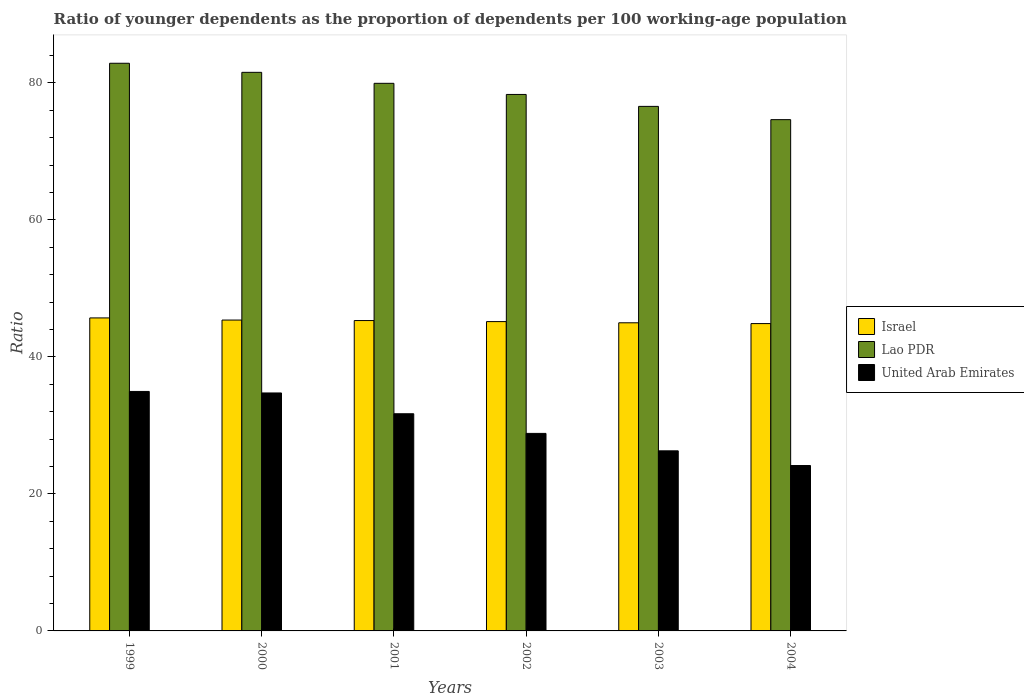How many bars are there on the 2nd tick from the left?
Ensure brevity in your answer.  3. How many bars are there on the 5th tick from the right?
Your answer should be very brief. 3. What is the label of the 1st group of bars from the left?
Give a very brief answer. 1999. What is the age dependency ratio(young) in Israel in 2000?
Offer a terse response. 45.38. Across all years, what is the maximum age dependency ratio(young) in United Arab Emirates?
Keep it short and to the point. 34.96. Across all years, what is the minimum age dependency ratio(young) in Israel?
Your response must be concise. 44.87. In which year was the age dependency ratio(young) in Lao PDR minimum?
Your answer should be compact. 2004. What is the total age dependency ratio(young) in Israel in the graph?
Make the answer very short. 271.39. What is the difference between the age dependency ratio(young) in Lao PDR in 1999 and that in 2002?
Offer a terse response. 4.55. What is the difference between the age dependency ratio(young) in Lao PDR in 2003 and the age dependency ratio(young) in Israel in 2002?
Offer a very short reply. 31.42. What is the average age dependency ratio(young) in Lao PDR per year?
Make the answer very short. 78.98. In the year 1999, what is the difference between the age dependency ratio(young) in Israel and age dependency ratio(young) in United Arab Emirates?
Your response must be concise. 10.73. In how many years, is the age dependency ratio(young) in United Arab Emirates greater than 12?
Provide a short and direct response. 6. What is the ratio of the age dependency ratio(young) in Lao PDR in 1999 to that in 2000?
Give a very brief answer. 1.02. Is the age dependency ratio(young) in Lao PDR in 1999 less than that in 2002?
Keep it short and to the point. No. Is the difference between the age dependency ratio(young) in Israel in 2000 and 2003 greater than the difference between the age dependency ratio(young) in United Arab Emirates in 2000 and 2003?
Make the answer very short. No. What is the difference between the highest and the second highest age dependency ratio(young) in Israel?
Provide a short and direct response. 0.31. What is the difference between the highest and the lowest age dependency ratio(young) in Lao PDR?
Offer a terse response. 8.23. In how many years, is the age dependency ratio(young) in Lao PDR greater than the average age dependency ratio(young) in Lao PDR taken over all years?
Keep it short and to the point. 3. Is the sum of the age dependency ratio(young) in United Arab Emirates in 2003 and 2004 greater than the maximum age dependency ratio(young) in Israel across all years?
Offer a very short reply. Yes. What does the 1st bar from the left in 1999 represents?
Your response must be concise. Israel. What does the 2nd bar from the right in 2004 represents?
Your answer should be very brief. Lao PDR. Is it the case that in every year, the sum of the age dependency ratio(young) in Lao PDR and age dependency ratio(young) in Israel is greater than the age dependency ratio(young) in United Arab Emirates?
Provide a succinct answer. Yes. How many bars are there?
Provide a short and direct response. 18. Are all the bars in the graph horizontal?
Provide a succinct answer. No. What is the difference between two consecutive major ticks on the Y-axis?
Your response must be concise. 20. Where does the legend appear in the graph?
Provide a succinct answer. Center right. How are the legend labels stacked?
Your response must be concise. Vertical. What is the title of the graph?
Your response must be concise. Ratio of younger dependents as the proportion of dependents per 100 working-age population. Does "Niger" appear as one of the legend labels in the graph?
Your answer should be very brief. No. What is the label or title of the Y-axis?
Your response must be concise. Ratio. What is the Ratio of Israel in 1999?
Give a very brief answer. 45.69. What is the Ratio in Lao PDR in 1999?
Ensure brevity in your answer.  82.87. What is the Ratio in United Arab Emirates in 1999?
Offer a terse response. 34.96. What is the Ratio of Israel in 2000?
Your response must be concise. 45.38. What is the Ratio of Lao PDR in 2000?
Your answer should be very brief. 81.54. What is the Ratio of United Arab Emirates in 2000?
Give a very brief answer. 34.74. What is the Ratio of Israel in 2001?
Offer a terse response. 45.31. What is the Ratio in Lao PDR in 2001?
Offer a very short reply. 79.94. What is the Ratio of United Arab Emirates in 2001?
Your answer should be compact. 31.7. What is the Ratio in Israel in 2002?
Give a very brief answer. 45.16. What is the Ratio of Lao PDR in 2002?
Your response must be concise. 78.32. What is the Ratio of United Arab Emirates in 2002?
Offer a terse response. 28.84. What is the Ratio in Israel in 2003?
Offer a terse response. 44.98. What is the Ratio of Lao PDR in 2003?
Make the answer very short. 76.57. What is the Ratio of United Arab Emirates in 2003?
Provide a short and direct response. 26.29. What is the Ratio of Israel in 2004?
Give a very brief answer. 44.87. What is the Ratio in Lao PDR in 2004?
Your response must be concise. 74.64. What is the Ratio in United Arab Emirates in 2004?
Give a very brief answer. 24.15. Across all years, what is the maximum Ratio in Israel?
Make the answer very short. 45.69. Across all years, what is the maximum Ratio in Lao PDR?
Keep it short and to the point. 82.87. Across all years, what is the maximum Ratio in United Arab Emirates?
Your answer should be very brief. 34.96. Across all years, what is the minimum Ratio in Israel?
Keep it short and to the point. 44.87. Across all years, what is the minimum Ratio of Lao PDR?
Your answer should be compact. 74.64. Across all years, what is the minimum Ratio in United Arab Emirates?
Provide a succinct answer. 24.15. What is the total Ratio of Israel in the graph?
Provide a succinct answer. 271.39. What is the total Ratio of Lao PDR in the graph?
Keep it short and to the point. 473.89. What is the total Ratio of United Arab Emirates in the graph?
Give a very brief answer. 180.67. What is the difference between the Ratio in Israel in 1999 and that in 2000?
Your answer should be very brief. 0.31. What is the difference between the Ratio in Lao PDR in 1999 and that in 2000?
Offer a very short reply. 1.33. What is the difference between the Ratio in United Arab Emirates in 1999 and that in 2000?
Your answer should be compact. 0.22. What is the difference between the Ratio in Israel in 1999 and that in 2001?
Ensure brevity in your answer.  0.39. What is the difference between the Ratio in Lao PDR in 1999 and that in 2001?
Offer a terse response. 2.93. What is the difference between the Ratio in United Arab Emirates in 1999 and that in 2001?
Make the answer very short. 3.26. What is the difference between the Ratio of Israel in 1999 and that in 2002?
Your response must be concise. 0.54. What is the difference between the Ratio in Lao PDR in 1999 and that in 2002?
Offer a very short reply. 4.55. What is the difference between the Ratio of United Arab Emirates in 1999 and that in 2002?
Offer a very short reply. 6.12. What is the difference between the Ratio of Israel in 1999 and that in 2003?
Provide a succinct answer. 0.71. What is the difference between the Ratio of Lao PDR in 1999 and that in 2003?
Provide a short and direct response. 6.3. What is the difference between the Ratio in United Arab Emirates in 1999 and that in 2003?
Make the answer very short. 8.67. What is the difference between the Ratio in Israel in 1999 and that in 2004?
Make the answer very short. 0.83. What is the difference between the Ratio of Lao PDR in 1999 and that in 2004?
Ensure brevity in your answer.  8.23. What is the difference between the Ratio in United Arab Emirates in 1999 and that in 2004?
Offer a terse response. 10.81. What is the difference between the Ratio in Israel in 2000 and that in 2001?
Provide a short and direct response. 0.07. What is the difference between the Ratio in Lao PDR in 2000 and that in 2001?
Offer a very short reply. 1.6. What is the difference between the Ratio in United Arab Emirates in 2000 and that in 2001?
Make the answer very short. 3.03. What is the difference between the Ratio in Israel in 2000 and that in 2002?
Offer a very short reply. 0.22. What is the difference between the Ratio of Lao PDR in 2000 and that in 2002?
Ensure brevity in your answer.  3.23. What is the difference between the Ratio in United Arab Emirates in 2000 and that in 2002?
Your answer should be compact. 5.9. What is the difference between the Ratio in Israel in 2000 and that in 2003?
Ensure brevity in your answer.  0.4. What is the difference between the Ratio of Lao PDR in 2000 and that in 2003?
Offer a terse response. 4.97. What is the difference between the Ratio in United Arab Emirates in 2000 and that in 2003?
Keep it short and to the point. 8.45. What is the difference between the Ratio in Israel in 2000 and that in 2004?
Make the answer very short. 0.51. What is the difference between the Ratio in Lao PDR in 2000 and that in 2004?
Your answer should be compact. 6.91. What is the difference between the Ratio in United Arab Emirates in 2000 and that in 2004?
Provide a short and direct response. 10.59. What is the difference between the Ratio in Israel in 2001 and that in 2002?
Your answer should be very brief. 0.15. What is the difference between the Ratio of Lao PDR in 2001 and that in 2002?
Your response must be concise. 1.62. What is the difference between the Ratio in United Arab Emirates in 2001 and that in 2002?
Offer a terse response. 2.87. What is the difference between the Ratio of Israel in 2001 and that in 2003?
Your response must be concise. 0.33. What is the difference between the Ratio in Lao PDR in 2001 and that in 2003?
Ensure brevity in your answer.  3.37. What is the difference between the Ratio of United Arab Emirates in 2001 and that in 2003?
Your response must be concise. 5.41. What is the difference between the Ratio in Israel in 2001 and that in 2004?
Provide a short and direct response. 0.44. What is the difference between the Ratio in Lao PDR in 2001 and that in 2004?
Your answer should be compact. 5.3. What is the difference between the Ratio in United Arab Emirates in 2001 and that in 2004?
Offer a terse response. 7.56. What is the difference between the Ratio in Israel in 2002 and that in 2003?
Give a very brief answer. 0.17. What is the difference between the Ratio of Lao PDR in 2002 and that in 2003?
Offer a terse response. 1.74. What is the difference between the Ratio of United Arab Emirates in 2002 and that in 2003?
Offer a very short reply. 2.55. What is the difference between the Ratio in Israel in 2002 and that in 2004?
Offer a terse response. 0.29. What is the difference between the Ratio of Lao PDR in 2002 and that in 2004?
Your answer should be compact. 3.68. What is the difference between the Ratio of United Arab Emirates in 2002 and that in 2004?
Give a very brief answer. 4.69. What is the difference between the Ratio of Israel in 2003 and that in 2004?
Offer a terse response. 0.12. What is the difference between the Ratio in Lao PDR in 2003 and that in 2004?
Your answer should be compact. 1.94. What is the difference between the Ratio of United Arab Emirates in 2003 and that in 2004?
Make the answer very short. 2.14. What is the difference between the Ratio of Israel in 1999 and the Ratio of Lao PDR in 2000?
Make the answer very short. -35.85. What is the difference between the Ratio in Israel in 1999 and the Ratio in United Arab Emirates in 2000?
Make the answer very short. 10.96. What is the difference between the Ratio of Lao PDR in 1999 and the Ratio of United Arab Emirates in 2000?
Provide a succinct answer. 48.13. What is the difference between the Ratio of Israel in 1999 and the Ratio of Lao PDR in 2001?
Ensure brevity in your answer.  -34.25. What is the difference between the Ratio in Israel in 1999 and the Ratio in United Arab Emirates in 2001?
Offer a terse response. 13.99. What is the difference between the Ratio in Lao PDR in 1999 and the Ratio in United Arab Emirates in 2001?
Give a very brief answer. 51.17. What is the difference between the Ratio in Israel in 1999 and the Ratio in Lao PDR in 2002?
Make the answer very short. -32.62. What is the difference between the Ratio in Israel in 1999 and the Ratio in United Arab Emirates in 2002?
Your response must be concise. 16.86. What is the difference between the Ratio in Lao PDR in 1999 and the Ratio in United Arab Emirates in 2002?
Give a very brief answer. 54.03. What is the difference between the Ratio in Israel in 1999 and the Ratio in Lao PDR in 2003?
Offer a terse response. -30.88. What is the difference between the Ratio in Israel in 1999 and the Ratio in United Arab Emirates in 2003?
Make the answer very short. 19.4. What is the difference between the Ratio of Lao PDR in 1999 and the Ratio of United Arab Emirates in 2003?
Offer a very short reply. 56.58. What is the difference between the Ratio of Israel in 1999 and the Ratio of Lao PDR in 2004?
Provide a succinct answer. -28.95. What is the difference between the Ratio of Israel in 1999 and the Ratio of United Arab Emirates in 2004?
Provide a short and direct response. 21.55. What is the difference between the Ratio in Lao PDR in 1999 and the Ratio in United Arab Emirates in 2004?
Make the answer very short. 58.72. What is the difference between the Ratio in Israel in 2000 and the Ratio in Lao PDR in 2001?
Offer a very short reply. -34.56. What is the difference between the Ratio of Israel in 2000 and the Ratio of United Arab Emirates in 2001?
Ensure brevity in your answer.  13.68. What is the difference between the Ratio of Lao PDR in 2000 and the Ratio of United Arab Emirates in 2001?
Keep it short and to the point. 49.84. What is the difference between the Ratio in Israel in 2000 and the Ratio in Lao PDR in 2002?
Ensure brevity in your answer.  -32.94. What is the difference between the Ratio in Israel in 2000 and the Ratio in United Arab Emirates in 2002?
Give a very brief answer. 16.55. What is the difference between the Ratio in Lao PDR in 2000 and the Ratio in United Arab Emirates in 2002?
Your answer should be very brief. 52.71. What is the difference between the Ratio in Israel in 2000 and the Ratio in Lao PDR in 2003?
Your response must be concise. -31.19. What is the difference between the Ratio of Israel in 2000 and the Ratio of United Arab Emirates in 2003?
Provide a short and direct response. 19.09. What is the difference between the Ratio in Lao PDR in 2000 and the Ratio in United Arab Emirates in 2003?
Provide a succinct answer. 55.25. What is the difference between the Ratio of Israel in 2000 and the Ratio of Lao PDR in 2004?
Your answer should be very brief. -29.26. What is the difference between the Ratio in Israel in 2000 and the Ratio in United Arab Emirates in 2004?
Offer a very short reply. 21.23. What is the difference between the Ratio in Lao PDR in 2000 and the Ratio in United Arab Emirates in 2004?
Offer a terse response. 57.4. What is the difference between the Ratio of Israel in 2001 and the Ratio of Lao PDR in 2002?
Offer a terse response. -33.01. What is the difference between the Ratio in Israel in 2001 and the Ratio in United Arab Emirates in 2002?
Provide a short and direct response. 16.47. What is the difference between the Ratio of Lao PDR in 2001 and the Ratio of United Arab Emirates in 2002?
Provide a succinct answer. 51.11. What is the difference between the Ratio of Israel in 2001 and the Ratio of Lao PDR in 2003?
Your response must be concise. -31.27. What is the difference between the Ratio in Israel in 2001 and the Ratio in United Arab Emirates in 2003?
Make the answer very short. 19.02. What is the difference between the Ratio in Lao PDR in 2001 and the Ratio in United Arab Emirates in 2003?
Keep it short and to the point. 53.65. What is the difference between the Ratio in Israel in 2001 and the Ratio in Lao PDR in 2004?
Keep it short and to the point. -29.33. What is the difference between the Ratio in Israel in 2001 and the Ratio in United Arab Emirates in 2004?
Give a very brief answer. 21.16. What is the difference between the Ratio of Lao PDR in 2001 and the Ratio of United Arab Emirates in 2004?
Your answer should be very brief. 55.8. What is the difference between the Ratio in Israel in 2002 and the Ratio in Lao PDR in 2003?
Your answer should be compact. -31.42. What is the difference between the Ratio in Israel in 2002 and the Ratio in United Arab Emirates in 2003?
Make the answer very short. 18.87. What is the difference between the Ratio of Lao PDR in 2002 and the Ratio of United Arab Emirates in 2003?
Ensure brevity in your answer.  52.03. What is the difference between the Ratio of Israel in 2002 and the Ratio of Lao PDR in 2004?
Provide a succinct answer. -29.48. What is the difference between the Ratio of Israel in 2002 and the Ratio of United Arab Emirates in 2004?
Your answer should be very brief. 21.01. What is the difference between the Ratio in Lao PDR in 2002 and the Ratio in United Arab Emirates in 2004?
Give a very brief answer. 54.17. What is the difference between the Ratio in Israel in 2003 and the Ratio in Lao PDR in 2004?
Offer a very short reply. -29.66. What is the difference between the Ratio in Israel in 2003 and the Ratio in United Arab Emirates in 2004?
Offer a terse response. 20.84. What is the difference between the Ratio of Lao PDR in 2003 and the Ratio of United Arab Emirates in 2004?
Make the answer very short. 52.43. What is the average Ratio in Israel per year?
Your answer should be very brief. 45.23. What is the average Ratio of Lao PDR per year?
Provide a succinct answer. 78.98. What is the average Ratio in United Arab Emirates per year?
Your response must be concise. 30.11. In the year 1999, what is the difference between the Ratio in Israel and Ratio in Lao PDR?
Your answer should be very brief. -37.18. In the year 1999, what is the difference between the Ratio of Israel and Ratio of United Arab Emirates?
Offer a terse response. 10.73. In the year 1999, what is the difference between the Ratio of Lao PDR and Ratio of United Arab Emirates?
Give a very brief answer. 47.91. In the year 2000, what is the difference between the Ratio in Israel and Ratio in Lao PDR?
Provide a succinct answer. -36.16. In the year 2000, what is the difference between the Ratio in Israel and Ratio in United Arab Emirates?
Your answer should be very brief. 10.64. In the year 2000, what is the difference between the Ratio in Lao PDR and Ratio in United Arab Emirates?
Your response must be concise. 46.81. In the year 2001, what is the difference between the Ratio in Israel and Ratio in Lao PDR?
Your response must be concise. -34.63. In the year 2001, what is the difference between the Ratio in Israel and Ratio in United Arab Emirates?
Your response must be concise. 13.61. In the year 2001, what is the difference between the Ratio of Lao PDR and Ratio of United Arab Emirates?
Offer a terse response. 48.24. In the year 2002, what is the difference between the Ratio in Israel and Ratio in Lao PDR?
Provide a succinct answer. -33.16. In the year 2002, what is the difference between the Ratio of Israel and Ratio of United Arab Emirates?
Keep it short and to the point. 16.32. In the year 2002, what is the difference between the Ratio in Lao PDR and Ratio in United Arab Emirates?
Offer a terse response. 49.48. In the year 2003, what is the difference between the Ratio of Israel and Ratio of Lao PDR?
Your response must be concise. -31.59. In the year 2003, what is the difference between the Ratio in Israel and Ratio in United Arab Emirates?
Offer a very short reply. 18.69. In the year 2003, what is the difference between the Ratio in Lao PDR and Ratio in United Arab Emirates?
Give a very brief answer. 50.28. In the year 2004, what is the difference between the Ratio in Israel and Ratio in Lao PDR?
Give a very brief answer. -29.77. In the year 2004, what is the difference between the Ratio in Israel and Ratio in United Arab Emirates?
Provide a short and direct response. 20.72. In the year 2004, what is the difference between the Ratio in Lao PDR and Ratio in United Arab Emirates?
Your answer should be very brief. 50.49. What is the ratio of the Ratio of Lao PDR in 1999 to that in 2000?
Offer a very short reply. 1.02. What is the ratio of the Ratio in United Arab Emirates in 1999 to that in 2000?
Make the answer very short. 1.01. What is the ratio of the Ratio of Israel in 1999 to that in 2001?
Your answer should be very brief. 1.01. What is the ratio of the Ratio of Lao PDR in 1999 to that in 2001?
Offer a terse response. 1.04. What is the ratio of the Ratio of United Arab Emirates in 1999 to that in 2001?
Your response must be concise. 1.1. What is the ratio of the Ratio in Israel in 1999 to that in 2002?
Give a very brief answer. 1.01. What is the ratio of the Ratio in Lao PDR in 1999 to that in 2002?
Offer a very short reply. 1.06. What is the ratio of the Ratio in United Arab Emirates in 1999 to that in 2002?
Your answer should be very brief. 1.21. What is the ratio of the Ratio of Israel in 1999 to that in 2003?
Your response must be concise. 1.02. What is the ratio of the Ratio of Lao PDR in 1999 to that in 2003?
Make the answer very short. 1.08. What is the ratio of the Ratio in United Arab Emirates in 1999 to that in 2003?
Your answer should be very brief. 1.33. What is the ratio of the Ratio in Israel in 1999 to that in 2004?
Make the answer very short. 1.02. What is the ratio of the Ratio of Lao PDR in 1999 to that in 2004?
Offer a very short reply. 1.11. What is the ratio of the Ratio in United Arab Emirates in 1999 to that in 2004?
Provide a succinct answer. 1.45. What is the ratio of the Ratio in Lao PDR in 2000 to that in 2001?
Provide a short and direct response. 1.02. What is the ratio of the Ratio of United Arab Emirates in 2000 to that in 2001?
Ensure brevity in your answer.  1.1. What is the ratio of the Ratio in Israel in 2000 to that in 2002?
Give a very brief answer. 1. What is the ratio of the Ratio of Lao PDR in 2000 to that in 2002?
Make the answer very short. 1.04. What is the ratio of the Ratio of United Arab Emirates in 2000 to that in 2002?
Keep it short and to the point. 1.2. What is the ratio of the Ratio in Israel in 2000 to that in 2003?
Provide a short and direct response. 1.01. What is the ratio of the Ratio of Lao PDR in 2000 to that in 2003?
Give a very brief answer. 1.06. What is the ratio of the Ratio in United Arab Emirates in 2000 to that in 2003?
Ensure brevity in your answer.  1.32. What is the ratio of the Ratio in Israel in 2000 to that in 2004?
Offer a very short reply. 1.01. What is the ratio of the Ratio of Lao PDR in 2000 to that in 2004?
Keep it short and to the point. 1.09. What is the ratio of the Ratio in United Arab Emirates in 2000 to that in 2004?
Make the answer very short. 1.44. What is the ratio of the Ratio in Lao PDR in 2001 to that in 2002?
Provide a succinct answer. 1.02. What is the ratio of the Ratio in United Arab Emirates in 2001 to that in 2002?
Provide a short and direct response. 1.1. What is the ratio of the Ratio of Lao PDR in 2001 to that in 2003?
Give a very brief answer. 1.04. What is the ratio of the Ratio of United Arab Emirates in 2001 to that in 2003?
Make the answer very short. 1.21. What is the ratio of the Ratio in Israel in 2001 to that in 2004?
Make the answer very short. 1.01. What is the ratio of the Ratio in Lao PDR in 2001 to that in 2004?
Give a very brief answer. 1.07. What is the ratio of the Ratio of United Arab Emirates in 2001 to that in 2004?
Your response must be concise. 1.31. What is the ratio of the Ratio in Israel in 2002 to that in 2003?
Make the answer very short. 1. What is the ratio of the Ratio of Lao PDR in 2002 to that in 2003?
Your answer should be compact. 1.02. What is the ratio of the Ratio of United Arab Emirates in 2002 to that in 2003?
Ensure brevity in your answer.  1.1. What is the ratio of the Ratio in Israel in 2002 to that in 2004?
Make the answer very short. 1.01. What is the ratio of the Ratio of Lao PDR in 2002 to that in 2004?
Your response must be concise. 1.05. What is the ratio of the Ratio of United Arab Emirates in 2002 to that in 2004?
Make the answer very short. 1.19. What is the ratio of the Ratio of Lao PDR in 2003 to that in 2004?
Provide a short and direct response. 1.03. What is the ratio of the Ratio of United Arab Emirates in 2003 to that in 2004?
Ensure brevity in your answer.  1.09. What is the difference between the highest and the second highest Ratio in Israel?
Your answer should be very brief. 0.31. What is the difference between the highest and the second highest Ratio in Lao PDR?
Your response must be concise. 1.33. What is the difference between the highest and the second highest Ratio of United Arab Emirates?
Ensure brevity in your answer.  0.22. What is the difference between the highest and the lowest Ratio of Israel?
Make the answer very short. 0.83. What is the difference between the highest and the lowest Ratio of Lao PDR?
Keep it short and to the point. 8.23. What is the difference between the highest and the lowest Ratio of United Arab Emirates?
Your response must be concise. 10.81. 